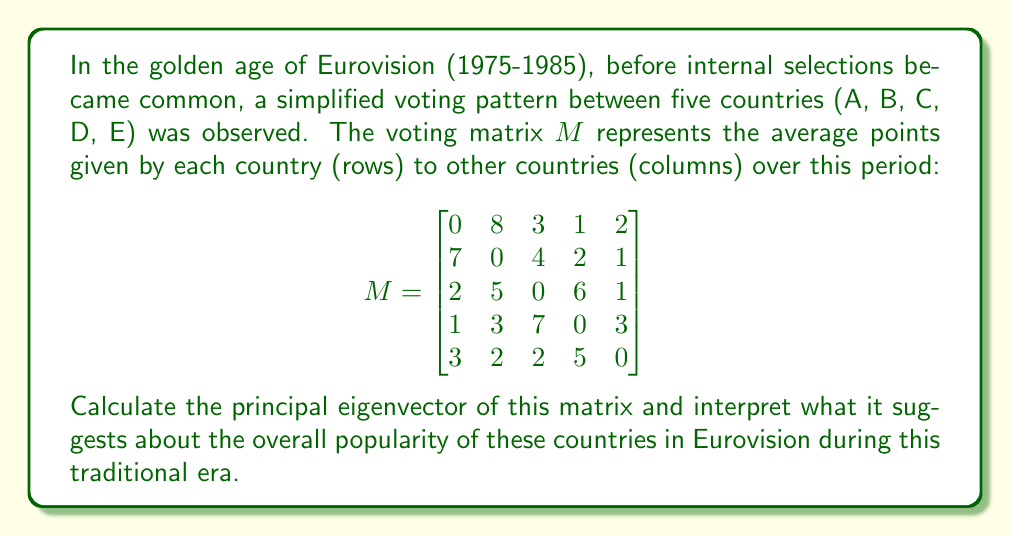Give your solution to this math problem. To find the principal eigenvector, we need to:

1) Find the eigenvalues of the matrix $M$.
2) Identify the largest eigenvalue (in absolute terms).
3) Find the corresponding eigenvector.

Step 1: Find the characteristic equation $\det(M - \lambda I) = 0$

The characteristic polynomial is:
$$\lambda^5 - 1124\lambda^3 + 3650\lambda^2 - 3316\lambda + 850 = 0$$

Step 2: Solve for eigenvalues

Using numerical methods, we find the eigenvalues:
$$\lambda_1 \approx 14.4729, \lambda_2 \approx -8.2366, \lambda_3 \approx -3.1181, \lambda_4 \approx 0.4409 + 2.8256i, \lambda_5 \approx 0.4409 - 2.8256i$$

The largest eigenvalue in absolute terms is $\lambda_1 \approx 14.4729$.

Step 3: Find the corresponding eigenvector

We solve $(M - 14.4729I)v = 0$ to find the eigenvector $v$:

$$v \approx \begin{bmatrix}
0.4684 \\
0.5197 \\
0.5118 \\
0.3708 \\
0.3293
\end{bmatrix}$$

This is the principal eigenvector.

Interpretation:
The components of the principal eigenvector represent the relative long-term influence or popularity of each country in this voting system. Higher values indicate greater popularity. 

In this case:
- Country B has the highest score (0.5197), suggesting it was the most popular overall.
- Countries A and C are close behind.
- Countries D and E were less popular in this traditional era.

This analysis provides insight into the historical voting patterns and relative popularity of these countries during the golden age of Eurovision, before internal selections became common.
Answer: Principal eigenvector: $[0.4684, 0.5197, 0.5118, 0.3708, 0.3293]^T$ 